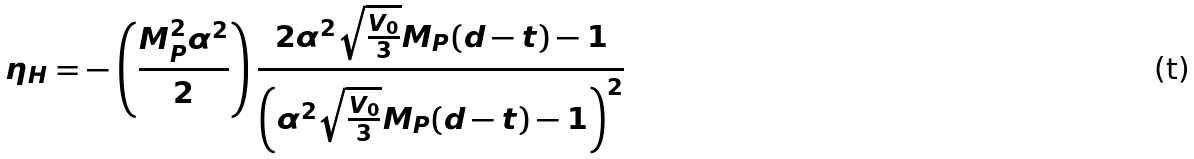<formula> <loc_0><loc_0><loc_500><loc_500>\eta _ { H } = - \left ( \frac { M _ { P } ^ { 2 } \alpha ^ { 2 } } { 2 } \right ) \frac { 2 \alpha ^ { 2 } \sqrt { \frac { V _ { 0 } } { 3 } } M _ { P } ( d - t ) - 1 } { \left ( \alpha ^ { 2 } \sqrt { \frac { V _ { 0 } } { 3 } } M _ { P } ( d - t ) - 1 \right ) ^ { 2 } }</formula> 